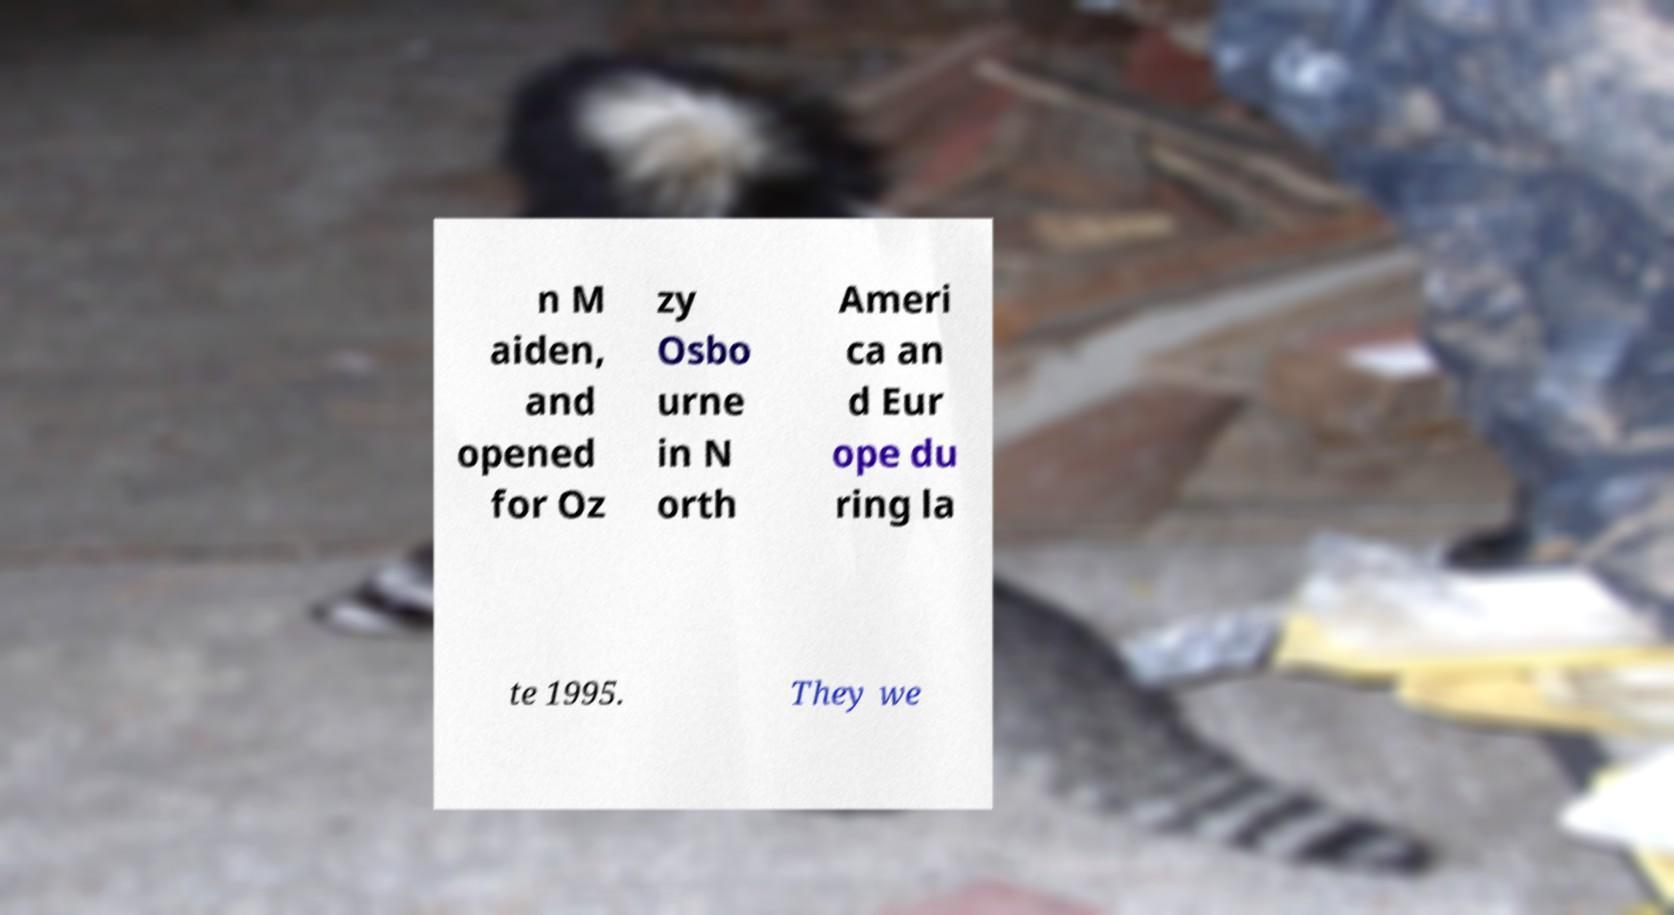I need the written content from this picture converted into text. Can you do that? n M aiden, and opened for Oz zy Osbo urne in N orth Ameri ca an d Eur ope du ring la te 1995. They we 